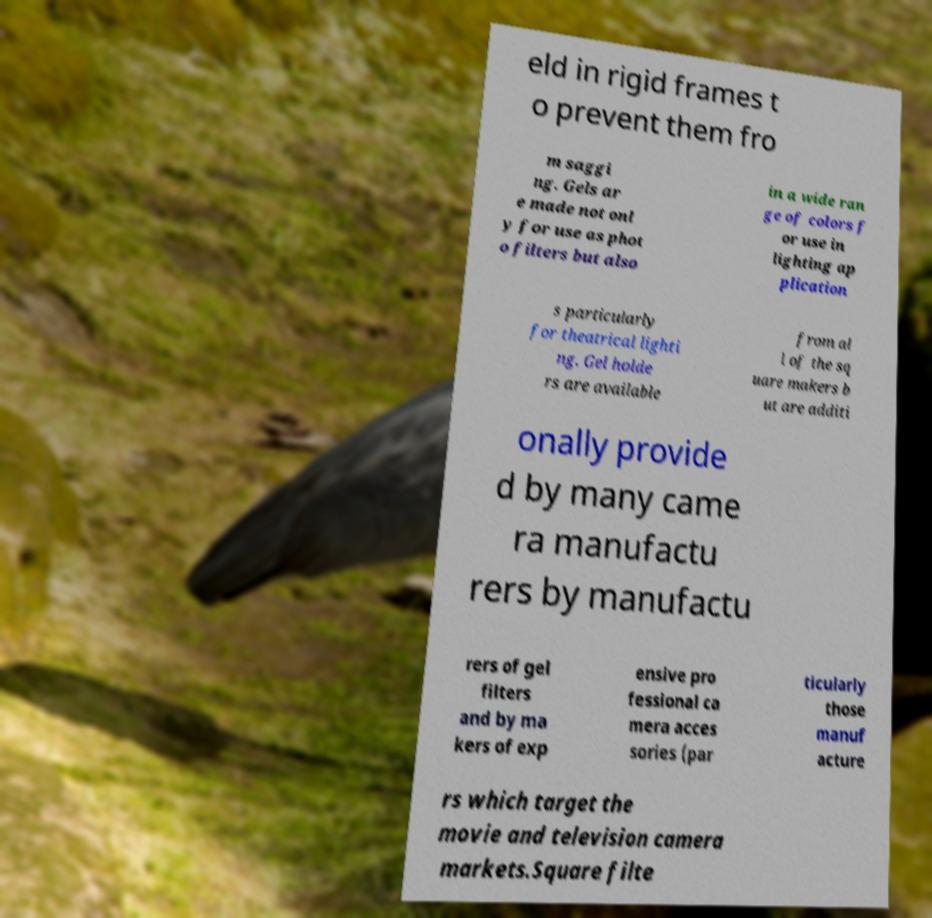Can you accurately transcribe the text from the provided image for me? eld in rigid frames t o prevent them fro m saggi ng. Gels ar e made not onl y for use as phot o filters but also in a wide ran ge of colors f or use in lighting ap plication s particularly for theatrical lighti ng. Gel holde rs are available from al l of the sq uare makers b ut are additi onally provide d by many came ra manufactu rers by manufactu rers of gel filters and by ma kers of exp ensive pro fessional ca mera acces sories (par ticularly those manuf acture rs which target the movie and television camera markets.Square filte 